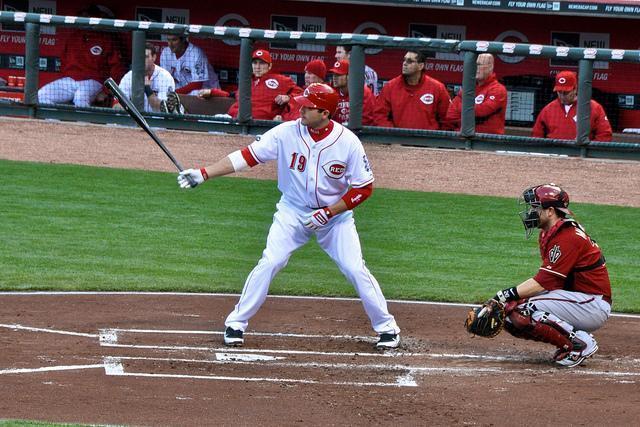How many people are standing behind the fence?
Give a very brief answer. 10. How many people are there?
Give a very brief answer. 8. 